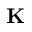<formula> <loc_0><loc_0><loc_500><loc_500>K</formula> 